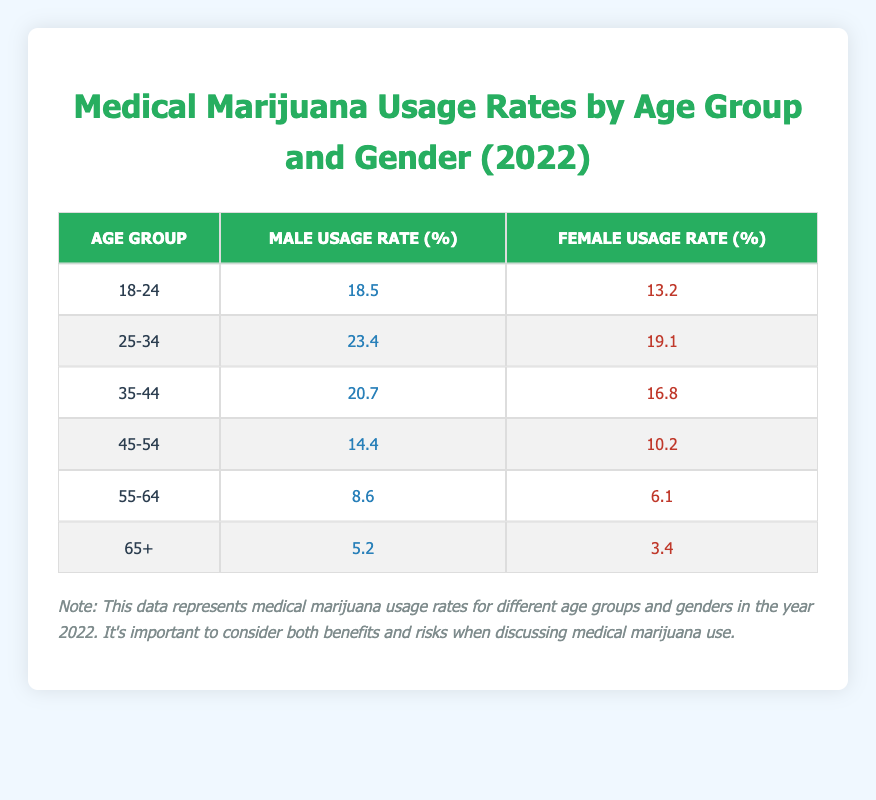What is the usage rate of medical marijuana among males aged 25-34? The table shows that the usage rate for males in the age group 25-34 is 23.4%.
Answer: 23.4% Which age group has the highest percentage of female medical marijuana users? By comparing the usage rates for females across all age groups, 25-34 has the highest usage rate at 19.1%.
Answer: 25-34 What is the difference in usage rates between males and females in the 18-24 age group? For males, the usage rate is 18.5%, and for females, it is 13.2%. The difference is calculated as 18.5 - 13.2 = 5.3%.
Answer: 5.3% What is the average usage rate for males across all age groups? Adding the male usage rates: (18.5 + 23.4 + 20.7 + 14.4 + 8.6 + 5.2) = 90.8. There are 6 age groups, so the average is 90.8 / 6 = 15.13%.
Answer: 15.13% Are there any age groups where female usage rates exceed 15%? Looking at the table, the usage rates for females are 13.2%, 19.1%, 16.8%, 10.2%, 6.1%, and 3.4%. Only the 25-34 and 35-44 age groups exceed 15%.
Answer: Yes What is the lowest usage rate for female medical marijuana users? The lowest usage rate for females is in the 65+ age group at 3.4%.
Answer: 3.4% What age group has the highest combined usage rate for both genders? The combined usage rates for each group are 18.5 + 13.2, 23.4 + 19.1, 20.7 + 16.8, 14.4 + 10.2, 8.6 + 6.1, and 5.2 + 3.4. The highest is 23.4 + 19.1 = 42.5% in the 25-34 age group.
Answer: 25-34 Is the usage rate for males in the 55-64 age group higher than that for females in the same age group? Males have a usage rate of 8.6% in the 55-64 age group, while females have 6.1%. Therefore, males have a higher rate.
Answer: Yes What is the total usage rate for males in age groups 45-54 and 55-64 combined? Adding the male usage rates for these age groups: 14.4% (45-54) + 8.6% (55-64) = 23%.
Answer: 23% How much lower is the usage rate for females aged 65+ compared to those aged 18-24? The usage rate for females aged 65+ is 3.4% and for 18-24 it's 13.2%. The difference is 13.2 - 3.4 = 9.8%.
Answer: 9.8% 